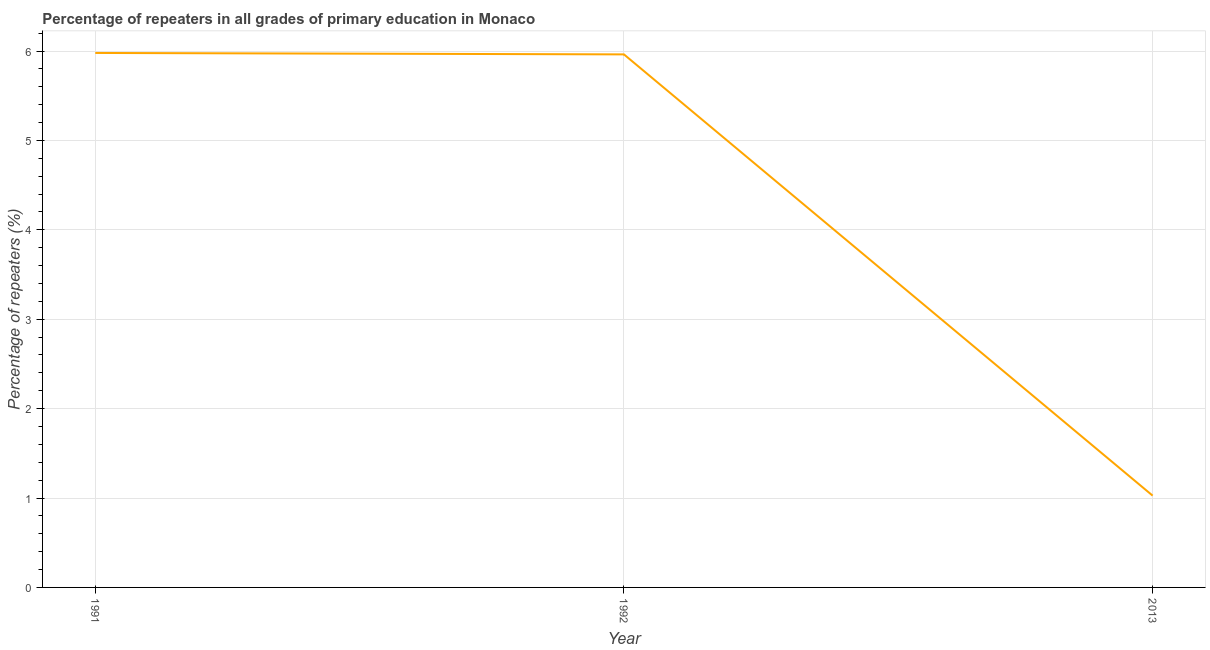What is the percentage of repeaters in primary education in 1991?
Make the answer very short. 5.98. Across all years, what is the maximum percentage of repeaters in primary education?
Your response must be concise. 5.98. Across all years, what is the minimum percentage of repeaters in primary education?
Your answer should be compact. 1.03. What is the sum of the percentage of repeaters in primary education?
Make the answer very short. 12.97. What is the difference between the percentage of repeaters in primary education in 1991 and 1992?
Your answer should be very brief. 0.02. What is the average percentage of repeaters in primary education per year?
Ensure brevity in your answer.  4.32. What is the median percentage of repeaters in primary education?
Your answer should be compact. 5.96. Do a majority of the years between 1991 and 1992 (inclusive) have percentage of repeaters in primary education greater than 5.4 %?
Offer a very short reply. Yes. What is the ratio of the percentage of repeaters in primary education in 1991 to that in 2013?
Make the answer very short. 5.82. Is the percentage of repeaters in primary education in 1991 less than that in 2013?
Your answer should be compact. No. Is the difference between the percentage of repeaters in primary education in 1991 and 1992 greater than the difference between any two years?
Provide a short and direct response. No. What is the difference between the highest and the second highest percentage of repeaters in primary education?
Keep it short and to the point. 0.02. Is the sum of the percentage of repeaters in primary education in 1991 and 1992 greater than the maximum percentage of repeaters in primary education across all years?
Your answer should be very brief. Yes. What is the difference between the highest and the lowest percentage of repeaters in primary education?
Provide a succinct answer. 4.95. What is the difference between two consecutive major ticks on the Y-axis?
Provide a succinct answer. 1. Are the values on the major ticks of Y-axis written in scientific E-notation?
Keep it short and to the point. No. Does the graph contain any zero values?
Provide a succinct answer. No. What is the title of the graph?
Provide a short and direct response. Percentage of repeaters in all grades of primary education in Monaco. What is the label or title of the X-axis?
Provide a succinct answer. Year. What is the label or title of the Y-axis?
Give a very brief answer. Percentage of repeaters (%). What is the Percentage of repeaters (%) of 1991?
Make the answer very short. 5.98. What is the Percentage of repeaters (%) in 1992?
Keep it short and to the point. 5.96. What is the Percentage of repeaters (%) in 2013?
Offer a very short reply. 1.03. What is the difference between the Percentage of repeaters (%) in 1991 and 1992?
Keep it short and to the point. 0.02. What is the difference between the Percentage of repeaters (%) in 1991 and 2013?
Provide a succinct answer. 4.95. What is the difference between the Percentage of repeaters (%) in 1992 and 2013?
Offer a terse response. 4.94. What is the ratio of the Percentage of repeaters (%) in 1991 to that in 2013?
Ensure brevity in your answer.  5.82. What is the ratio of the Percentage of repeaters (%) in 1992 to that in 2013?
Your answer should be compact. 5.81. 